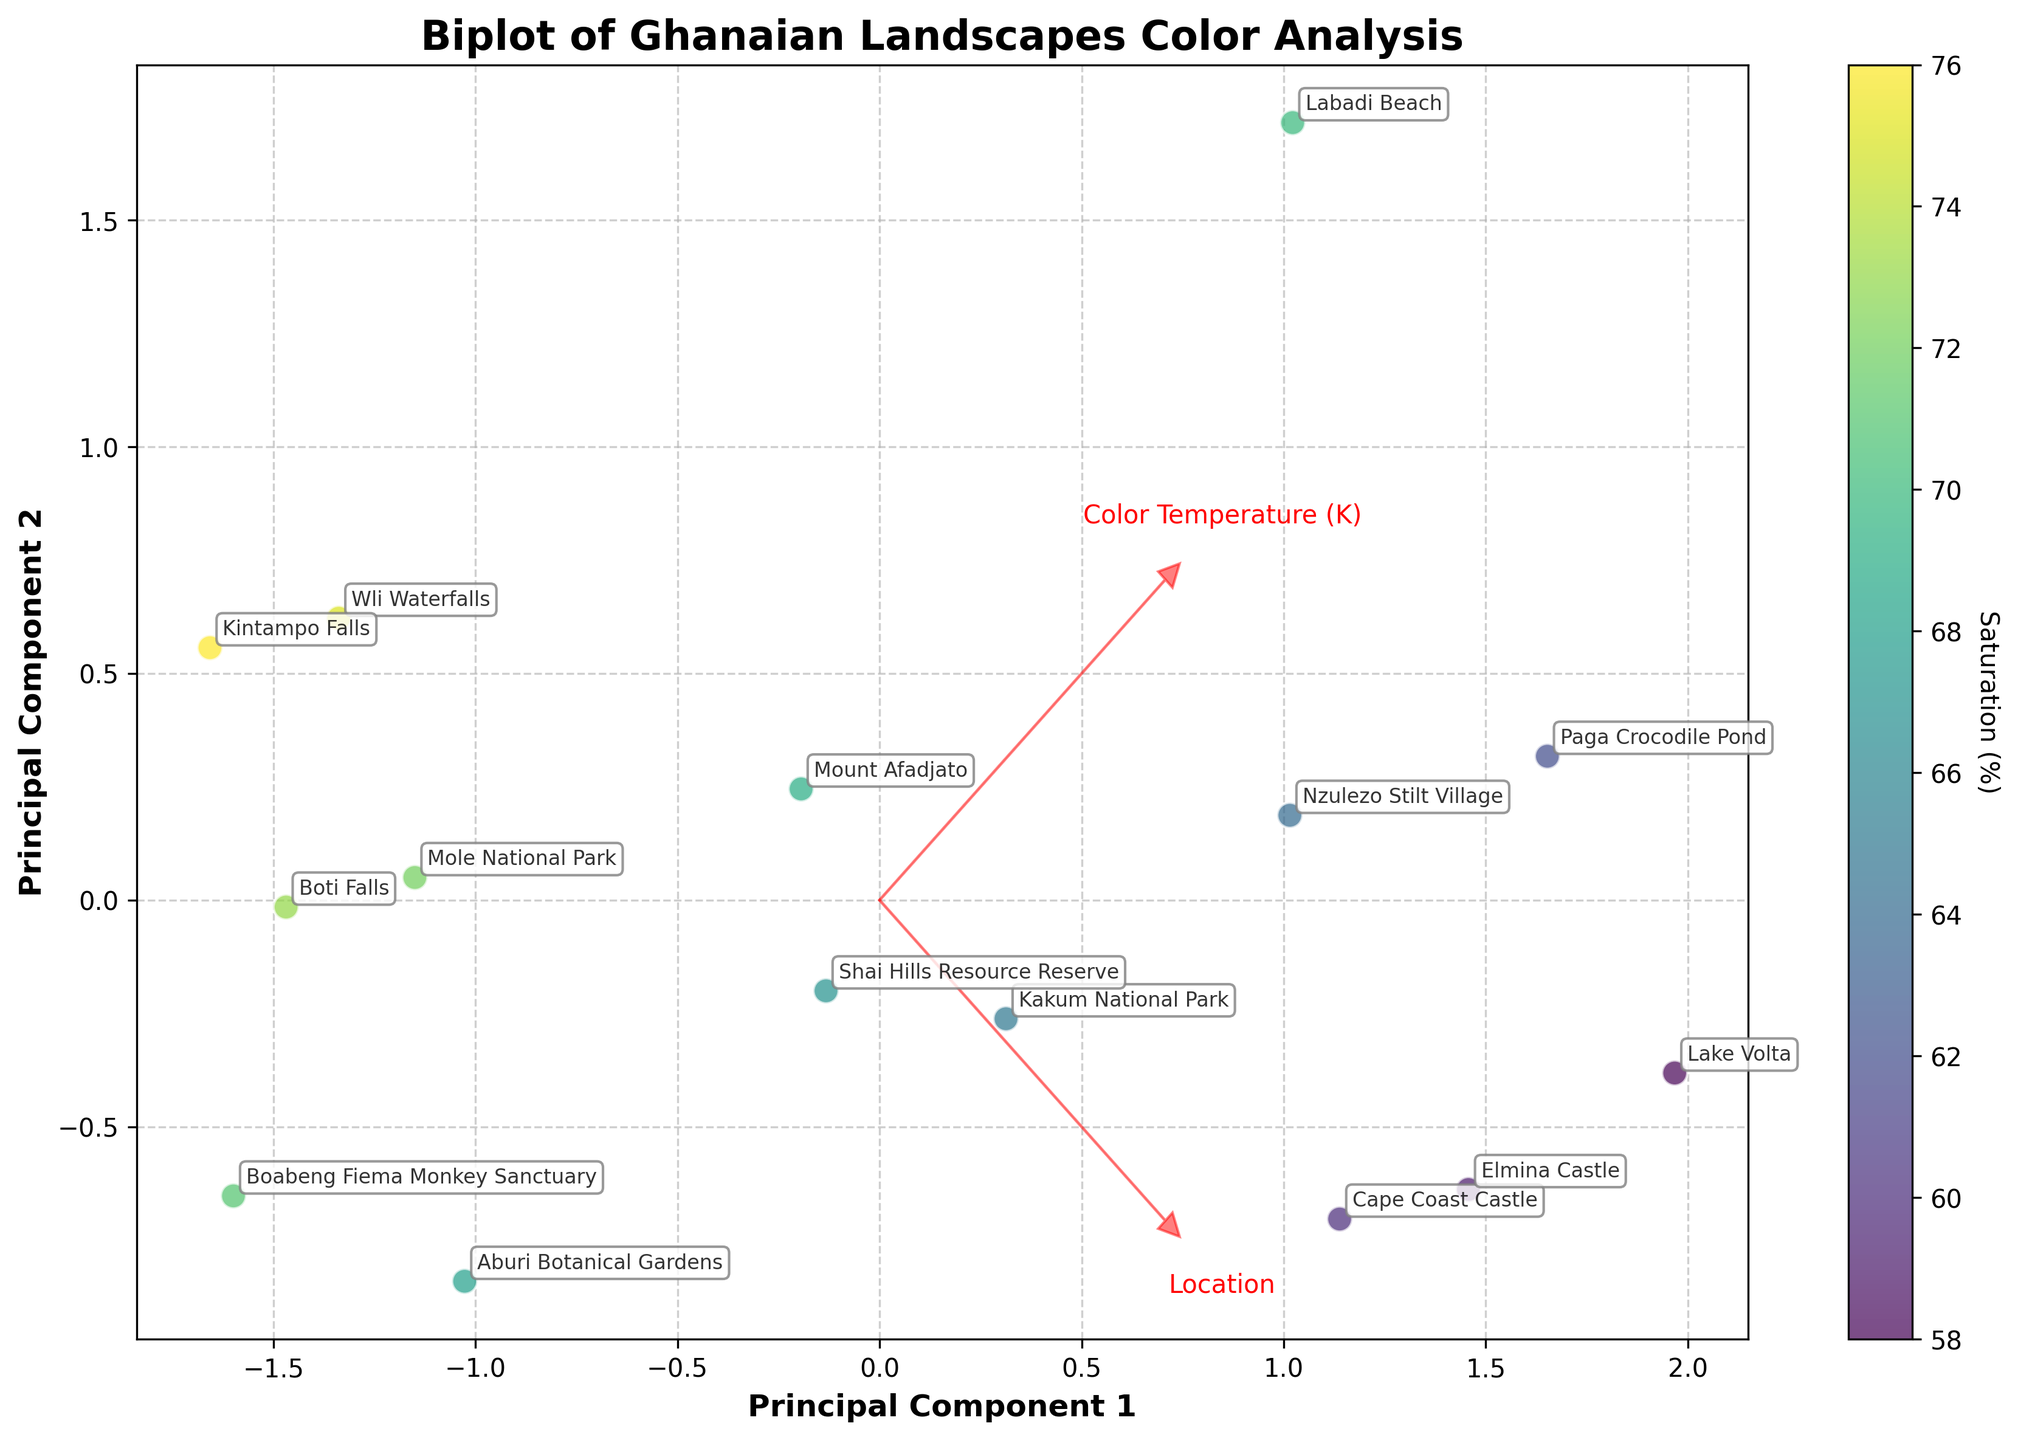what's the title of the figure? The title is located at the top center of the figure. It provides an overall description of what the figure represents.
Answer: Biplot of Ghanaian Landscapes Color Analysis how many data points are represented in the figure? Each data point corresponds to a location labeled on the biplot. By counting these labeled points, we get the total number of data points.
Answer: 15 which location has the highest saturation? Look for the data point with the highest value on the color bar, which represents saturation percentage. Refer to the label of this point.
Answer: Kintampo Falls which locations have a color temperature above 6000K? Identify the points located in the right side of the plot (along the Color Temperature arrow) and check their labels. Points with color temperature above 6000K will be on the positive side of the Color Temperature vector.
Answer: Lake Volta, Labadi Beach, Paga Crocodile Pond what is the principal component 1 value for Cape Coast Castle? Find the Cape Coast Castle data point on the plot and note its position on the Principal Component 1 axis, which is the x-axis.
Answer: Approximately 0.3 which locations are closest to the origin? Locate the points that are closest to (0, 0) on the plot, referring to both x (Principal Component 1) and y (Principal Component 2) coordinates.
Answer: Cape Coast Castle, Shai Hills Resource Reserve, Boabeng Fiema Monkey Sanctuary how does the color temperature of Kakum National Park compare to that of Mole National Park? Check the projected points for both locations on the plot and compare their positions along the Color Temperature vector (which is usually oriented along the Principal Component 1 axis).
Answer: Kakum National Park has a higher color temperature what does the arrow for 'Color Temperature (K)' represent? This arrow indicates the direction and magnitude of how the variable 'Color Temperature (K)' contributes to the principal components. It shows the correlation between the variable and the principal components.
Answer: Direction and contribution of Color Temperature (K) to the principal components if you move from left to right on the principal component 2 axis, how does saturation (%) change? Moving from left to right on the Principal Component 2 axis, watch the change on the color bar which represents saturation.
Answer: Saturation decreases 